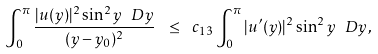Convert formula to latex. <formula><loc_0><loc_0><loc_500><loc_500>\int _ { 0 } ^ { \pi } \frac { | u ( y ) | ^ { 2 } \sin ^ { 2 } y \ D y } { ( y - y _ { 0 } ) ^ { 2 } } \ \leq \ c _ { 1 3 } \int _ { 0 } ^ { \pi } | u ^ { \prime } ( y ) | ^ { 2 } \sin ^ { 2 } y \ D y ,</formula> 